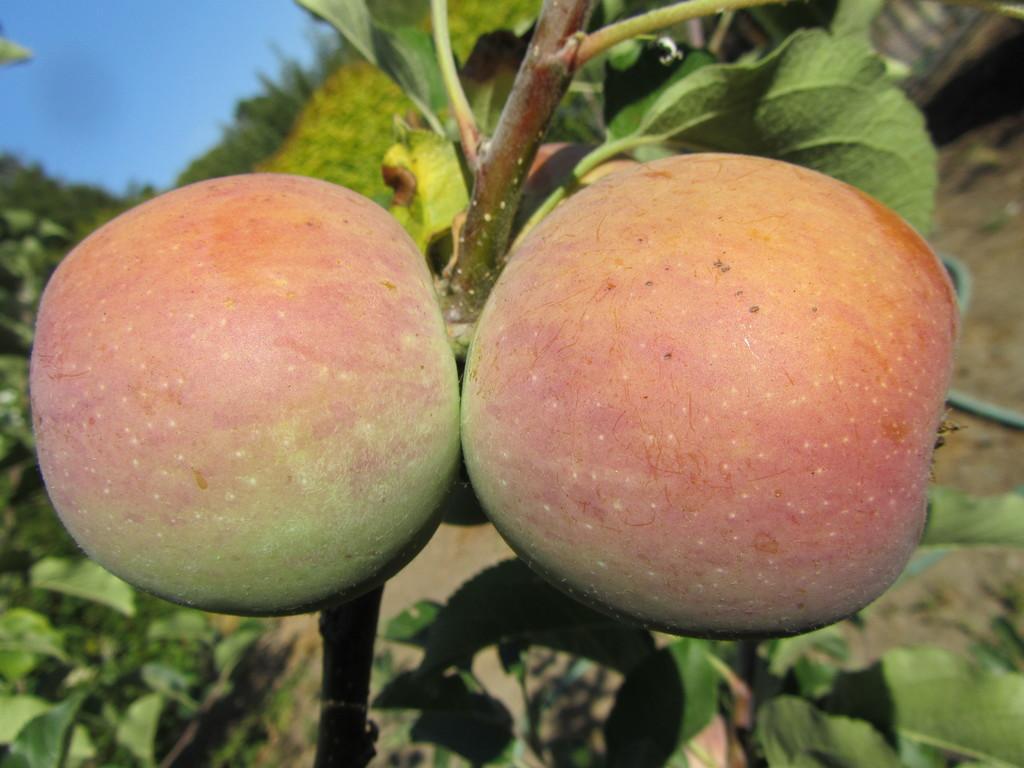In one or two sentences, can you explain what this image depicts? In this picture we can see 2 apples and green leaves. 